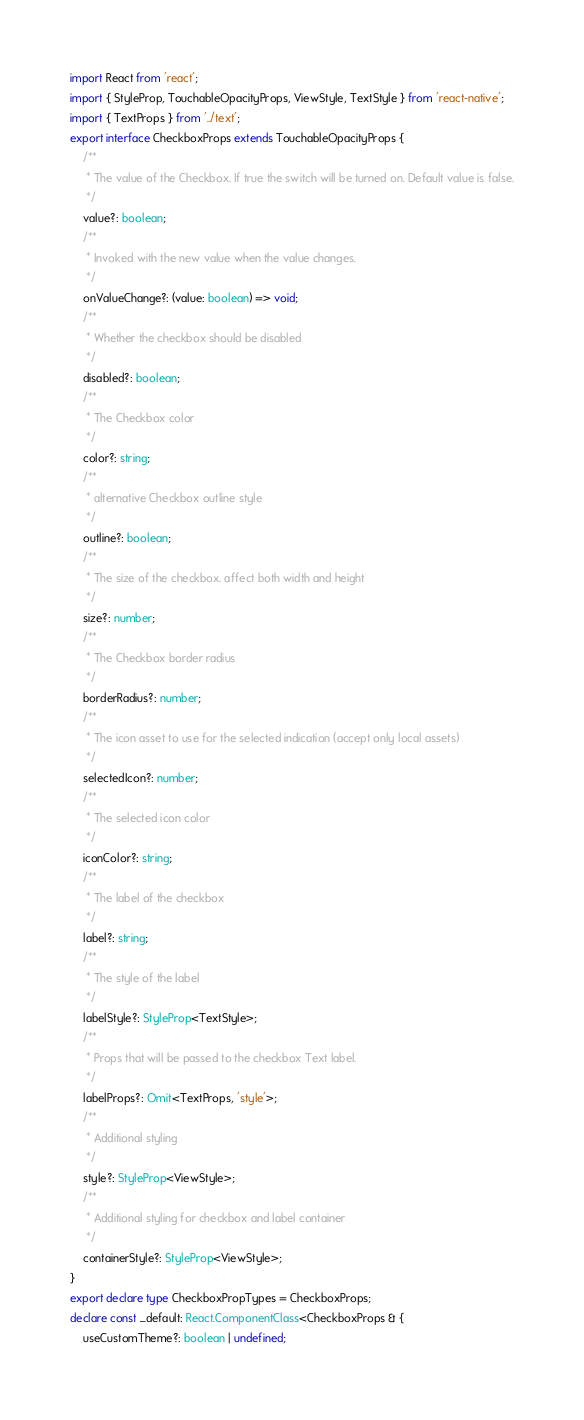<code> <loc_0><loc_0><loc_500><loc_500><_TypeScript_>import React from 'react';
import { StyleProp, TouchableOpacityProps, ViewStyle, TextStyle } from 'react-native';
import { TextProps } from '../text';
export interface CheckboxProps extends TouchableOpacityProps {
    /**
     * The value of the Checkbox. If true the switch will be turned on. Default value is false.
     */
    value?: boolean;
    /**
     * Invoked with the new value when the value changes.
     */
    onValueChange?: (value: boolean) => void;
    /**
     * Whether the checkbox should be disabled
     */
    disabled?: boolean;
    /**
     * The Checkbox color
     */
    color?: string;
    /**
     * alternative Checkbox outline style
     */
    outline?: boolean;
    /**
     * The size of the checkbox. affect both width and height
     */
    size?: number;
    /**
     * The Checkbox border radius
     */
    borderRadius?: number;
    /**
     * The icon asset to use for the selected indication (accept only local assets)
     */
    selectedIcon?: number;
    /**
     * The selected icon color
     */
    iconColor?: string;
    /**
     * The label of the checkbox
     */
    label?: string;
    /**
     * The style of the label
     */
    labelStyle?: StyleProp<TextStyle>;
    /**
     * Props that will be passed to the checkbox Text label.
     */
    labelProps?: Omit<TextProps, 'style'>;
    /**
     * Additional styling
     */
    style?: StyleProp<ViewStyle>;
    /**
     * Additional styling for checkbox and label container
     */
    containerStyle?: StyleProp<ViewStyle>;
}
export declare type CheckboxPropTypes = CheckboxProps;
declare const _default: React.ComponentClass<CheckboxProps & {
    useCustomTheme?: boolean | undefined;</code> 